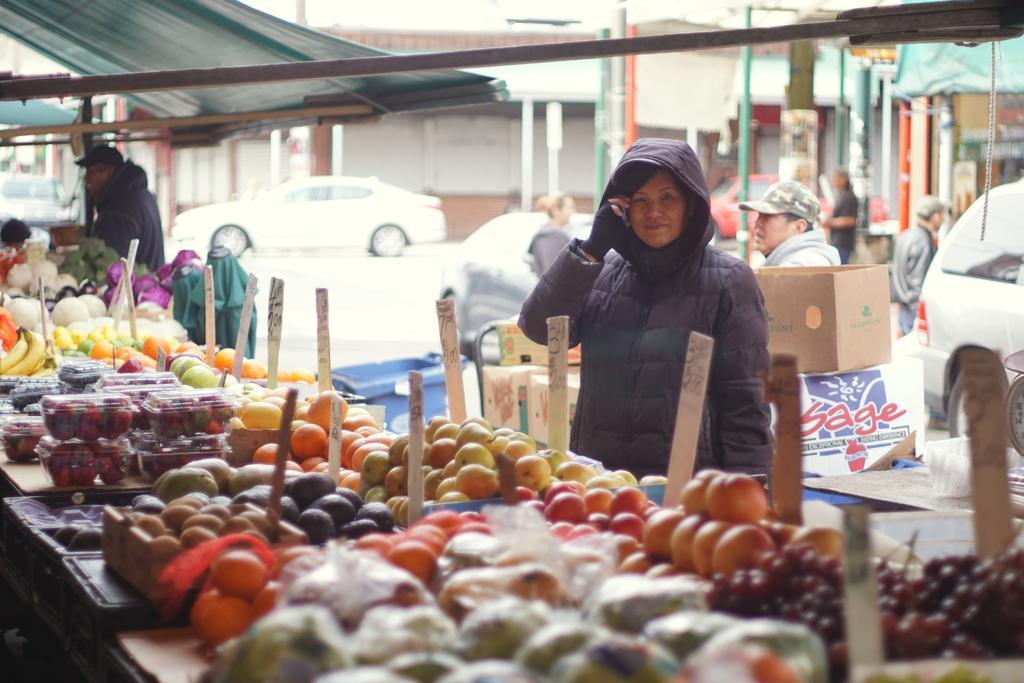How would you summarize this image in a sentence or two? In the center of the image there are fruits on the table. There is a lady wearing a jacket. In the background of the image there are buildings. There is a road on which there are cars, there are people. 